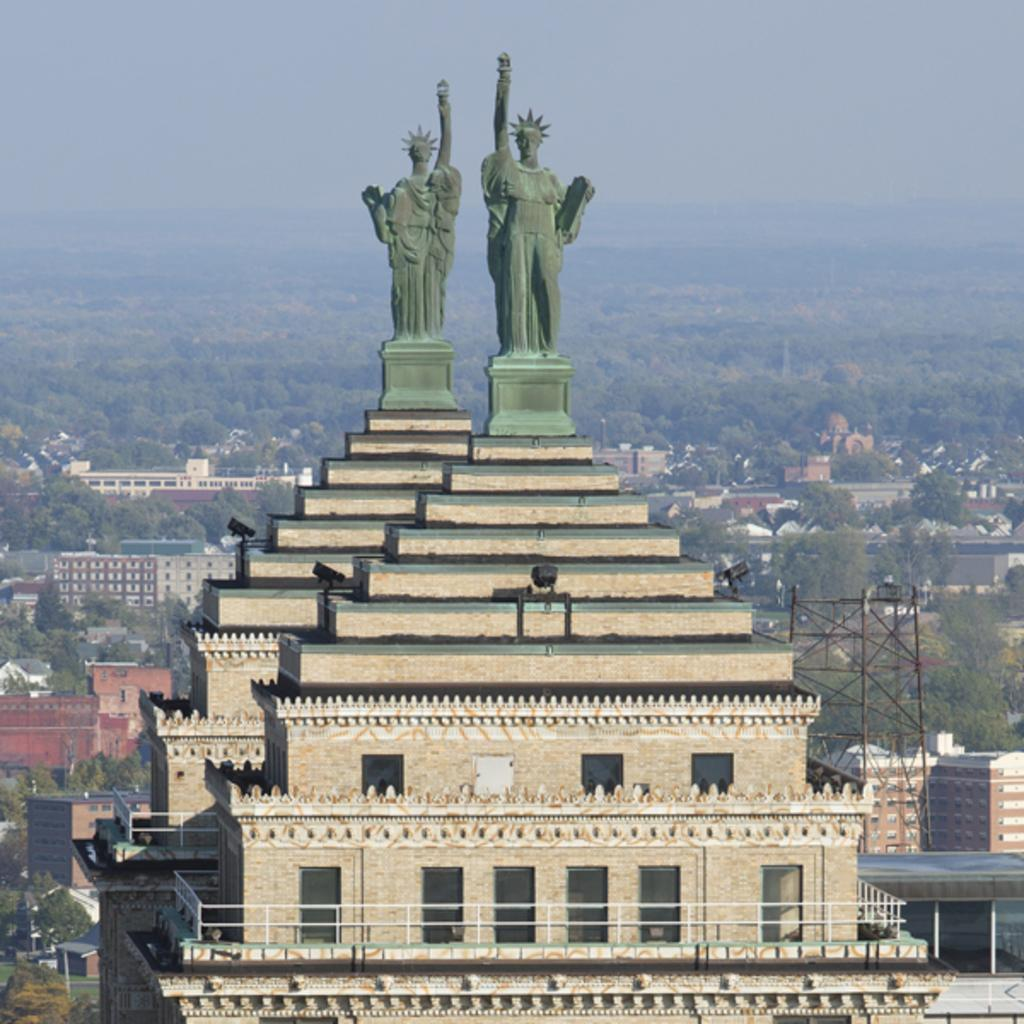What type of structures are present in the image? There are buildings in the image. What feature do the buildings have? The buildings have windows. What other elements can be seen in the image besides the buildings? There are trees, poles, lights, and green color statues in the image. What is the color of the sky in the image? The sky is blue in color. What type of dress is the snow wearing in the image? There is no snow or dress present in the image. What language are the statues speaking in the image? The statues are not speaking in the image, and there is no indication of any language being used. 